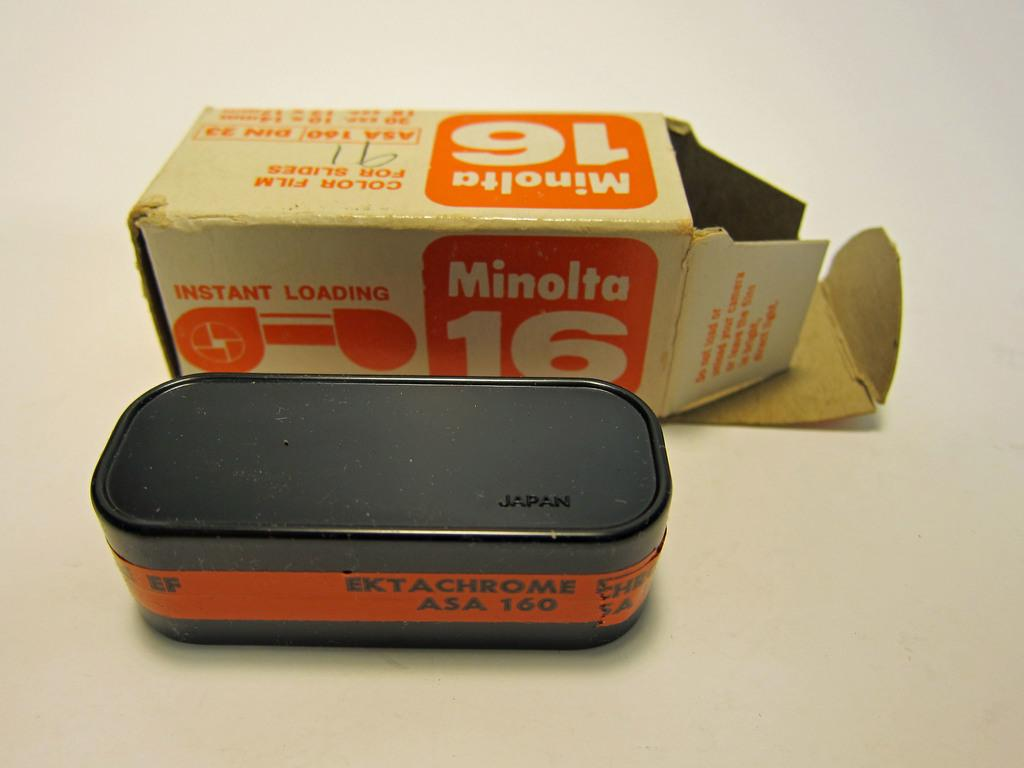Provide a one-sentence caption for the provided image. A canister of instant loading film from Minolta. 